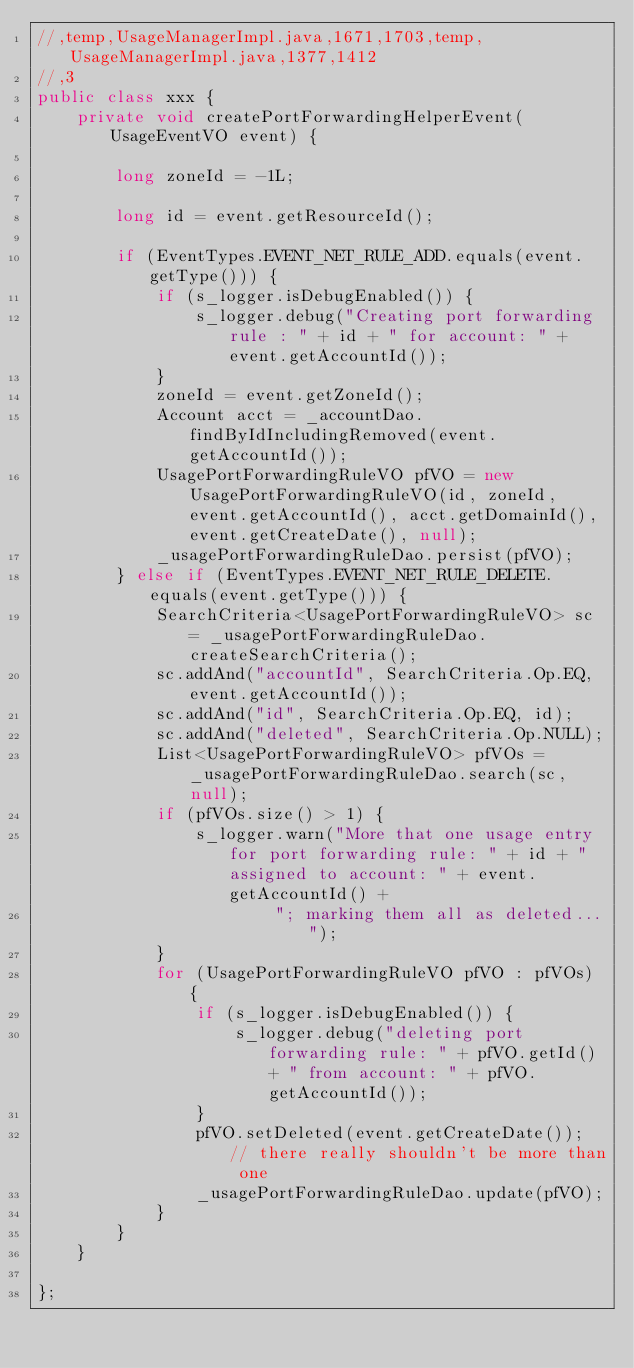Convert code to text. <code><loc_0><loc_0><loc_500><loc_500><_Java_>//,temp,UsageManagerImpl.java,1671,1703,temp,UsageManagerImpl.java,1377,1412
//,3
public class xxx {
    private void createPortForwardingHelperEvent(UsageEventVO event) {

        long zoneId = -1L;

        long id = event.getResourceId();

        if (EventTypes.EVENT_NET_RULE_ADD.equals(event.getType())) {
            if (s_logger.isDebugEnabled()) {
                s_logger.debug("Creating port forwarding rule : " + id + " for account: " + event.getAccountId());
            }
            zoneId = event.getZoneId();
            Account acct = _accountDao.findByIdIncludingRemoved(event.getAccountId());
            UsagePortForwardingRuleVO pfVO = new UsagePortForwardingRuleVO(id, zoneId, event.getAccountId(), acct.getDomainId(), event.getCreateDate(), null);
            _usagePortForwardingRuleDao.persist(pfVO);
        } else if (EventTypes.EVENT_NET_RULE_DELETE.equals(event.getType())) {
            SearchCriteria<UsagePortForwardingRuleVO> sc = _usagePortForwardingRuleDao.createSearchCriteria();
            sc.addAnd("accountId", SearchCriteria.Op.EQ, event.getAccountId());
            sc.addAnd("id", SearchCriteria.Op.EQ, id);
            sc.addAnd("deleted", SearchCriteria.Op.NULL);
            List<UsagePortForwardingRuleVO> pfVOs = _usagePortForwardingRuleDao.search(sc, null);
            if (pfVOs.size() > 1) {
                s_logger.warn("More that one usage entry for port forwarding rule: " + id + " assigned to account: " + event.getAccountId() +
                        "; marking them all as deleted...");
            }
            for (UsagePortForwardingRuleVO pfVO : pfVOs) {
                if (s_logger.isDebugEnabled()) {
                    s_logger.debug("deleting port forwarding rule: " + pfVO.getId() + " from account: " + pfVO.getAccountId());
                }
                pfVO.setDeleted(event.getCreateDate()); // there really shouldn't be more than one
                _usagePortForwardingRuleDao.update(pfVO);
            }
        }
    }

};</code> 